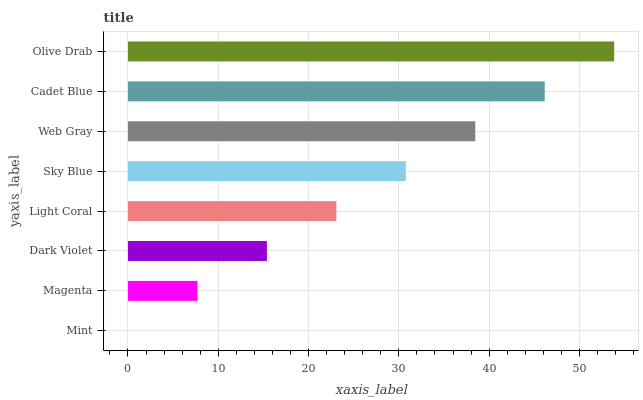Is Mint the minimum?
Answer yes or no. Yes. Is Olive Drab the maximum?
Answer yes or no. Yes. Is Magenta the minimum?
Answer yes or no. No. Is Magenta the maximum?
Answer yes or no. No. Is Magenta greater than Mint?
Answer yes or no. Yes. Is Mint less than Magenta?
Answer yes or no. Yes. Is Mint greater than Magenta?
Answer yes or no. No. Is Magenta less than Mint?
Answer yes or no. No. Is Sky Blue the high median?
Answer yes or no. Yes. Is Light Coral the low median?
Answer yes or no. Yes. Is Light Coral the high median?
Answer yes or no. No. Is Cadet Blue the low median?
Answer yes or no. No. 